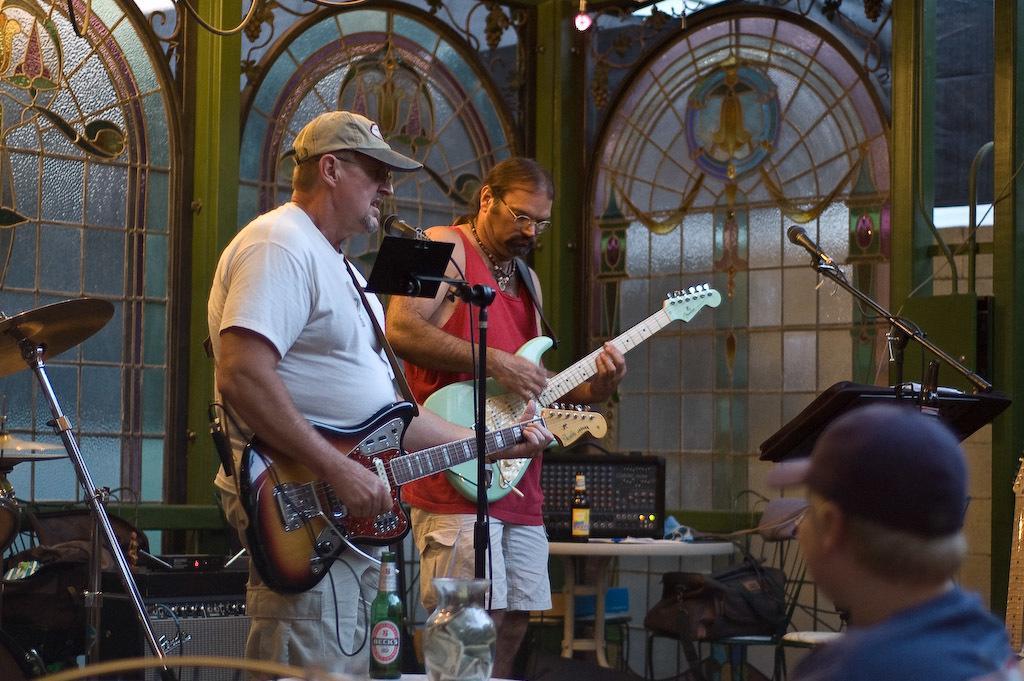Could you give a brief overview of what you see in this image? In this image there are group of persons who are playing musical instruments and in front of them there are microphones and at the background of the image there are doors. 